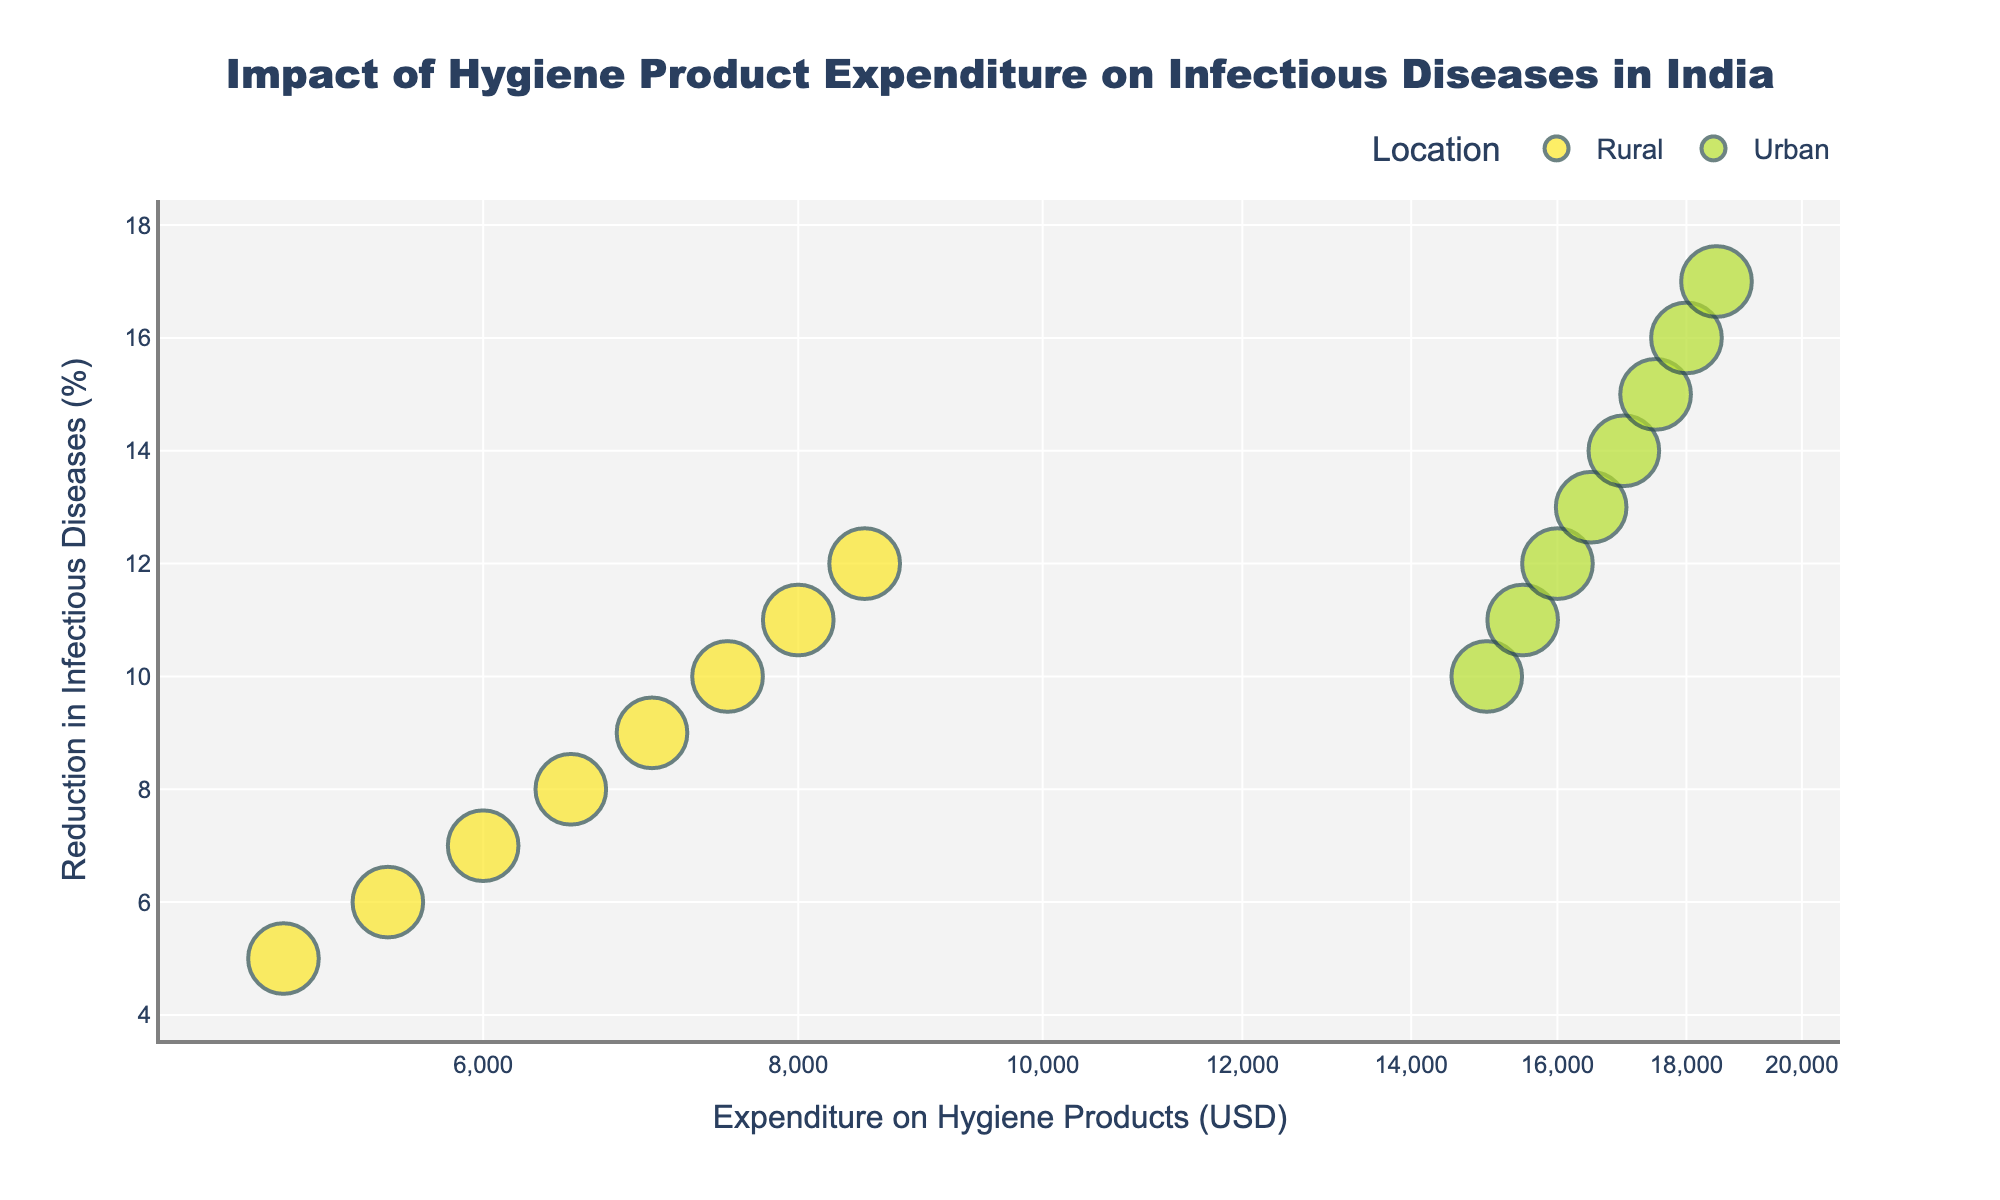What are the two different locations represented in the scatter plot? The figure uses two different colors to represent 'Rural' and 'Urban' locations. By looking at the legend, you can see these representations.
Answer: Rural and Urban Which year shows the highest reduction in infectious diseases in Urban India? The y-axis represents the reduction in infectious diseases (%), and you can see that the highest point for Urban India corresponds to the year 2022.
Answer: 2022 How does the expenditure on hygiene products in Rural India change from 2015 to 2022? Observing the x-axis for Rural India data points from 2015 to 2022 shows a gradual increase in expenditure, from $5000 in 2015 to $8500 in 2022.
Answer: Increase by $3500 Comparing Rural and Urban India, which has a higher reduction in infectious diseases for the same expenditure on hygiene products? For the same expenditure, Urban India tends to have a higher reduction in infectious diseases compared to Rural India, as seen by the generally higher placement of Urban points on the y-axis.
Answer: Urban India What is the relationship between expenditure on hygiene products and reduction in infectious diseases in Rural India? There is a positive correlation in Rural India; as the expenditure increases, the reduction in infectious diseases also increases, as seen by the upward trend of the Rural data points.
Answer: Positive correlation How does the reduction in infectious diseases change in Urban India from 2015 to 2022? By looking at the points for Urban India on the y-axis from 2015 to 2022, there is a consistent increase in reduction, starting from 10% in 2015 to 17% in 2022.
Answer: Increase by 7% Which year had the highest expenditure on hygiene products in Rural India? Referring to the x-axis for Rural India data points, the highest expenditure is seen in the year 2022 with $8500.
Answer: 2022 On a log scale, what is the range of expenditures for hygiene products shown in the scatter plot? The x-axis is on a log scale, and the range of expenditures spans from $5000 to $18500.
Answer: $5000 to $18500 Is there a clear distinction in the expenditure values between Rural and Urban India? Yes, Urban India consistently has higher expenditure values compared to Rural India, as indicated by the separation of the points on the x-axis.
Answer: Yes What trend can be observed in Urban India regarding the reduction in infectious diseases from 2015 to 2022 with respect to year-wise data points? Each data point for Urban India shows an increase in the reduction of infectious diseases over the years, with a continuous upward movement on the y-axis.
Answer: Continuous increase 